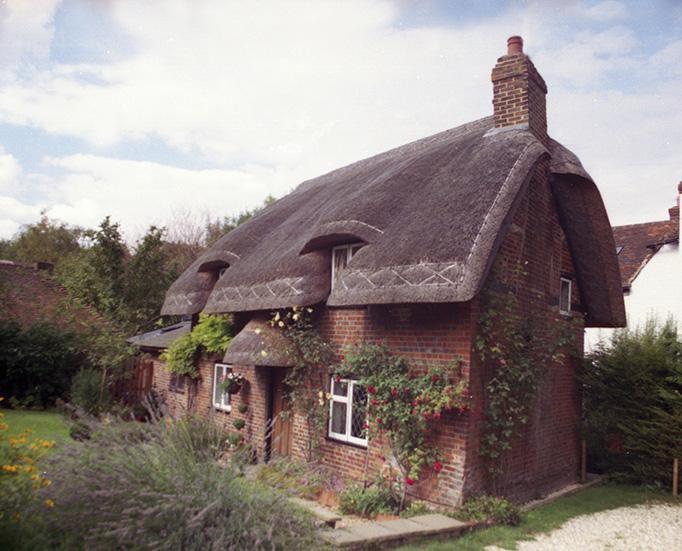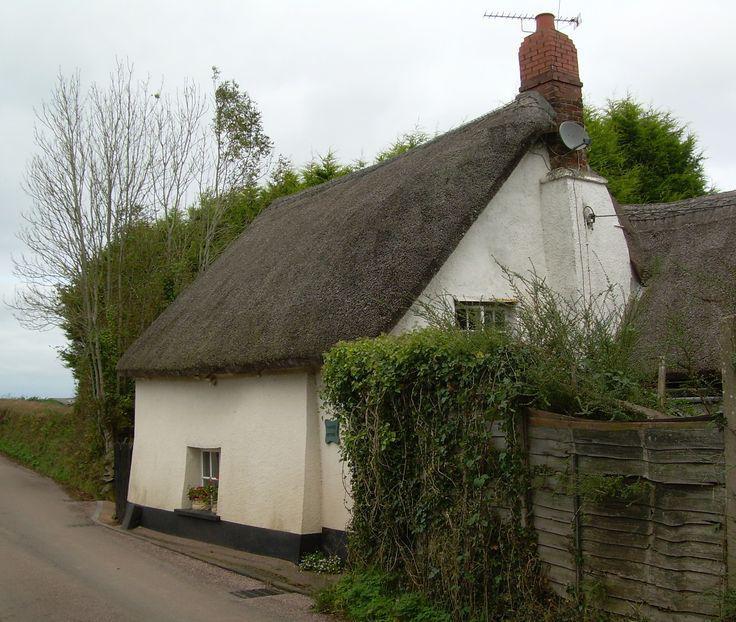The first image is the image on the left, the second image is the image on the right. Considering the images on both sides, is "There is exactly one brick chimney." valid? Answer yes or no. No. The first image is the image on the left, the second image is the image on the right. Assess this claim about the two images: "The roof in the left image is straight across the bottom and forms a simple triangle shape.". Correct or not? Answer yes or no. No. 